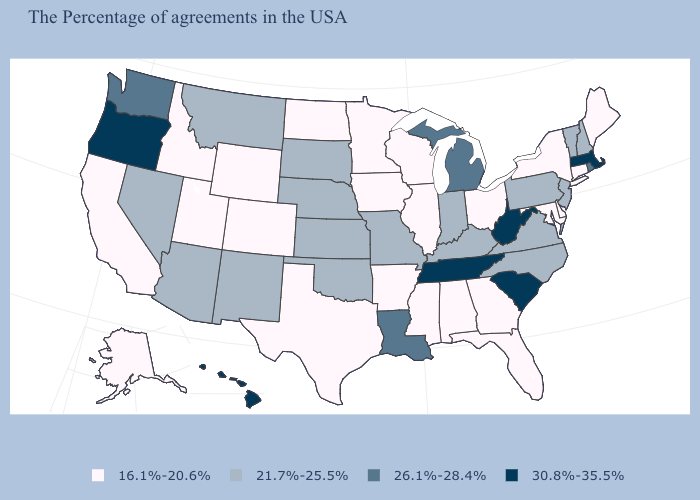What is the lowest value in the South?
Write a very short answer. 16.1%-20.6%. Name the states that have a value in the range 26.1%-28.4%?
Quick response, please. Rhode Island, Michigan, Louisiana, Washington. How many symbols are there in the legend?
Quick response, please. 4. Name the states that have a value in the range 30.8%-35.5%?
Keep it brief. Massachusetts, South Carolina, West Virginia, Tennessee, Oregon, Hawaii. What is the value of Vermont?
Keep it brief. 21.7%-25.5%. What is the value of New Hampshire?
Write a very short answer. 21.7%-25.5%. What is the lowest value in the USA?
Short answer required. 16.1%-20.6%. What is the value of California?
Keep it brief. 16.1%-20.6%. What is the lowest value in the USA?
Answer briefly. 16.1%-20.6%. Does Vermont have the same value as Kansas?
Write a very short answer. Yes. What is the highest value in states that border Montana?
Short answer required. 21.7%-25.5%. Name the states that have a value in the range 16.1%-20.6%?
Answer briefly. Maine, Connecticut, New York, Delaware, Maryland, Ohio, Florida, Georgia, Alabama, Wisconsin, Illinois, Mississippi, Arkansas, Minnesota, Iowa, Texas, North Dakota, Wyoming, Colorado, Utah, Idaho, California, Alaska. Name the states that have a value in the range 30.8%-35.5%?
Be succinct. Massachusetts, South Carolina, West Virginia, Tennessee, Oregon, Hawaii. Does the map have missing data?
Give a very brief answer. No. Does Oregon have a lower value than New Mexico?
Be succinct. No. 